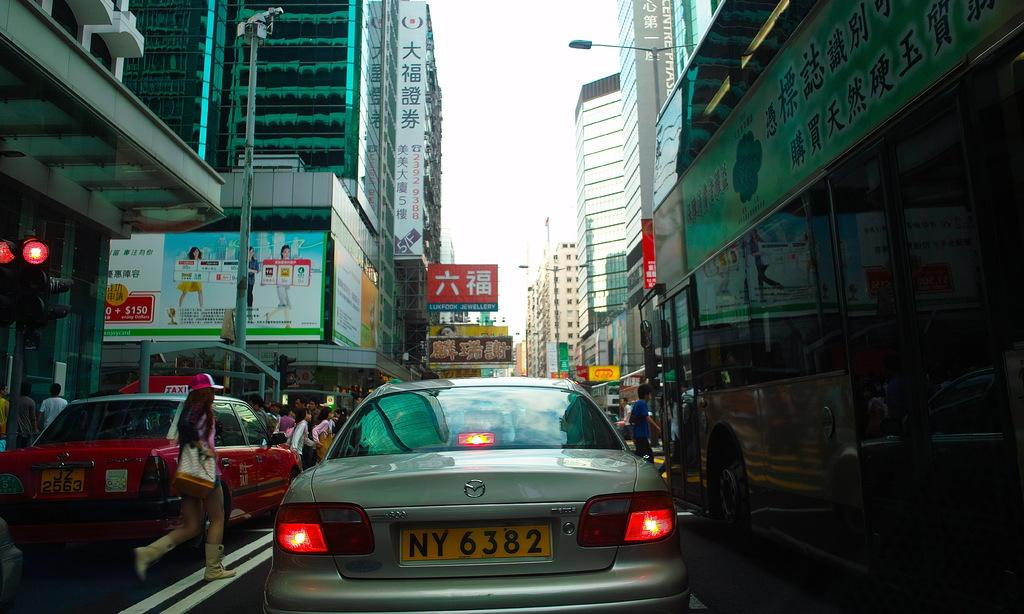<image>
Provide a brief description of the given image. A car with the license plate NY 6282 is stuck in a traffic jam as people walk around the cars. 